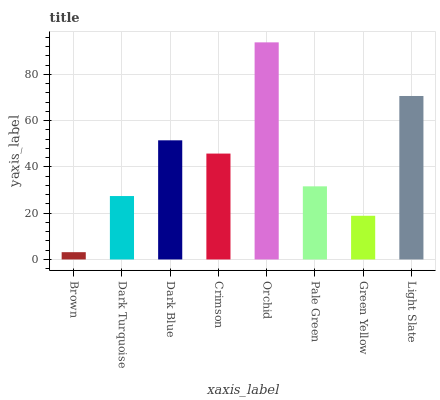Is Dark Turquoise the minimum?
Answer yes or no. No. Is Dark Turquoise the maximum?
Answer yes or no. No. Is Dark Turquoise greater than Brown?
Answer yes or no. Yes. Is Brown less than Dark Turquoise?
Answer yes or no. Yes. Is Brown greater than Dark Turquoise?
Answer yes or no. No. Is Dark Turquoise less than Brown?
Answer yes or no. No. Is Crimson the high median?
Answer yes or no. Yes. Is Pale Green the low median?
Answer yes or no. Yes. Is Light Slate the high median?
Answer yes or no. No. Is Green Yellow the low median?
Answer yes or no. No. 